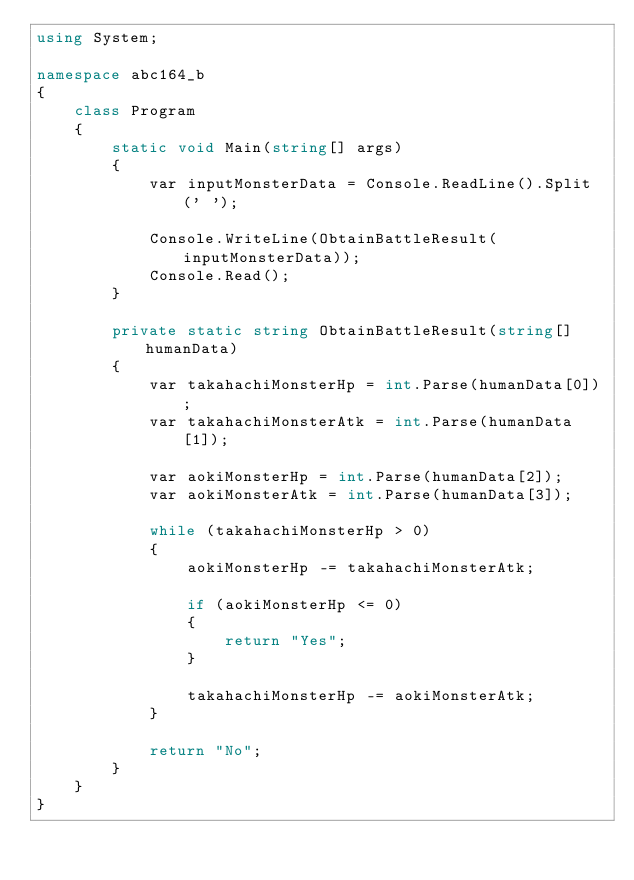<code> <loc_0><loc_0><loc_500><loc_500><_C#_>using System;

namespace abc164_b
{
    class Program
    {
        static void Main(string[] args)
        {
            var inputMonsterData = Console.ReadLine().Split(' ');

            Console.WriteLine(ObtainBattleResult(inputMonsterData));
            Console.Read();
        }

        private static string ObtainBattleResult(string[] humanData)
        {
            var takahachiMonsterHp = int.Parse(humanData[0]);
            var takahachiMonsterAtk = int.Parse(humanData[1]);

            var aokiMonsterHp = int.Parse(humanData[2]);
            var aokiMonsterAtk = int.Parse(humanData[3]);

            while (takahachiMonsterHp > 0)
            {
                aokiMonsterHp -= takahachiMonsterAtk;

                if (aokiMonsterHp <= 0)
                {
                    return "Yes";
                }

                takahachiMonsterHp -= aokiMonsterAtk;
            }

            return "No";
        }
    }
}</code> 